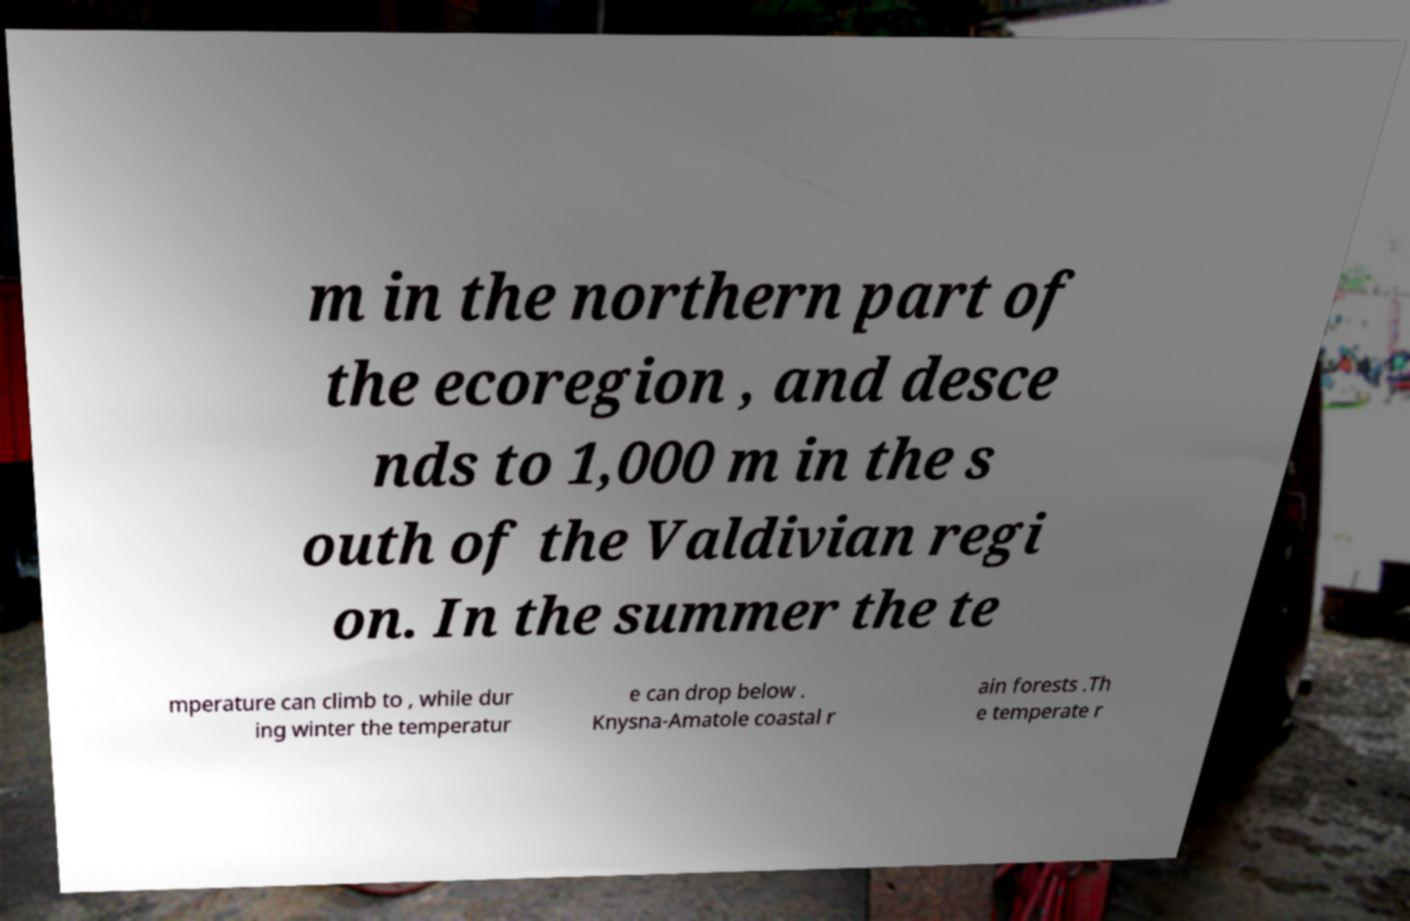For documentation purposes, I need the text within this image transcribed. Could you provide that? m in the northern part of the ecoregion , and desce nds to 1,000 m in the s outh of the Valdivian regi on. In the summer the te mperature can climb to , while dur ing winter the temperatur e can drop below . Knysna-Amatole coastal r ain forests .Th e temperate r 